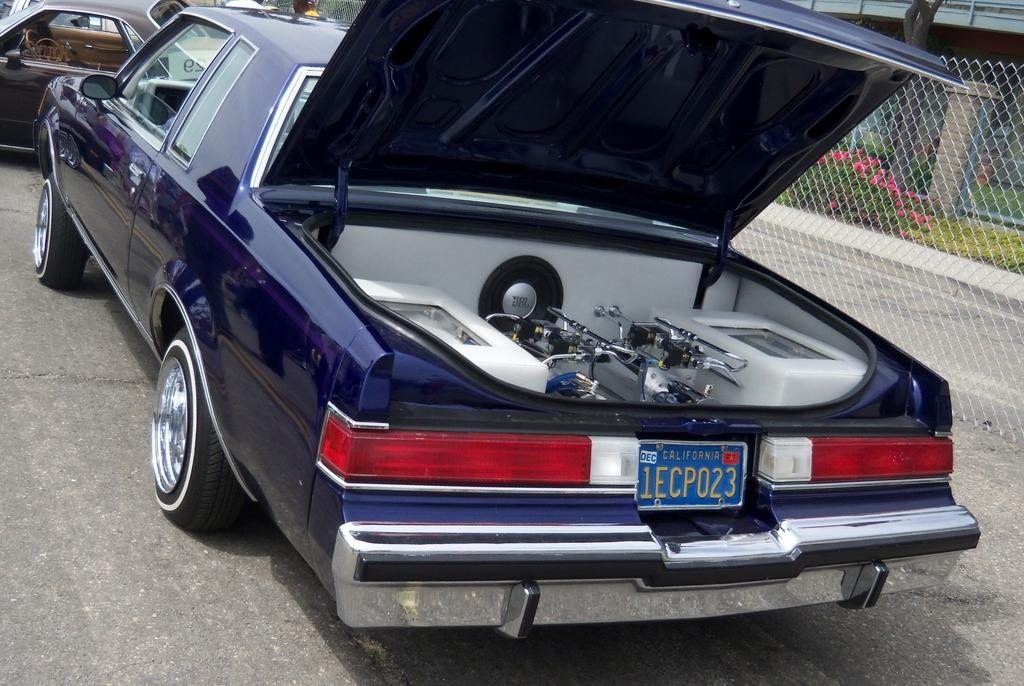<image>
Relay a brief, clear account of the picture shown. a license plate with 1EC on the back 